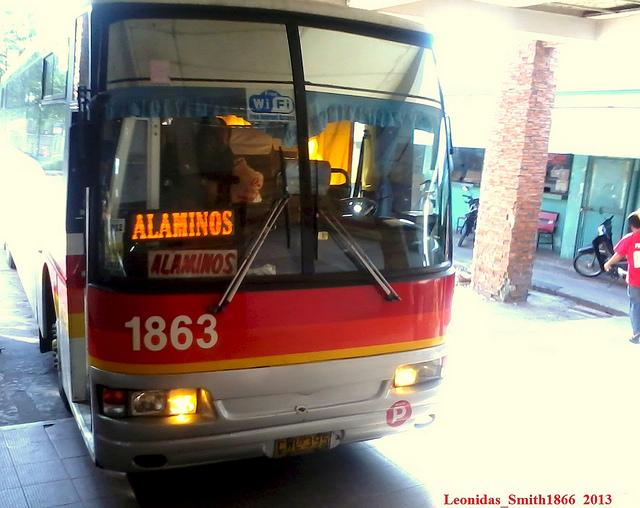What are the metal poles on the window called? Please explain your reasoning. wipes. A bus has long metal objects on the windshield used when it rains. 